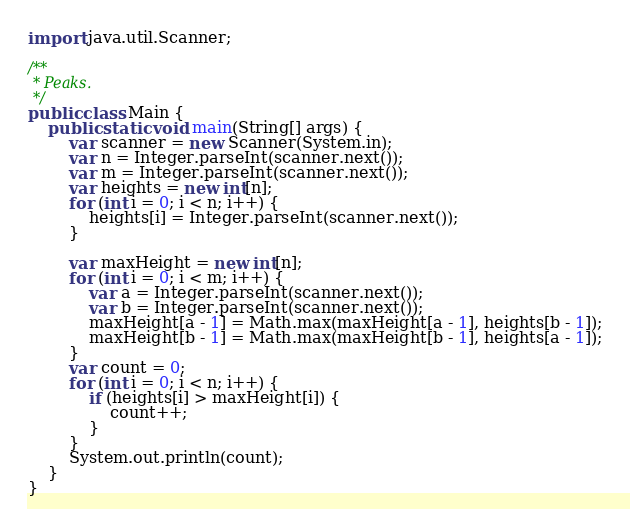<code> <loc_0><loc_0><loc_500><loc_500><_Java_>import java.util.Scanner;

/**
 * Peaks.
 */
public class Main {
    public static void main(String[] args) {
        var scanner = new Scanner(System.in);
        var n = Integer.parseInt(scanner.next());
        var m = Integer.parseInt(scanner.next());
        var heights = new int[n];
        for (int i = 0; i < n; i++) {
            heights[i] = Integer.parseInt(scanner.next());
        }

        var maxHeight = new int[n];
        for (int i = 0; i < m; i++) {
            var a = Integer.parseInt(scanner.next());
            var b = Integer.parseInt(scanner.next());
            maxHeight[a - 1] = Math.max(maxHeight[a - 1], heights[b - 1]);
            maxHeight[b - 1] = Math.max(maxHeight[b - 1], heights[a - 1]);
        }
        var count = 0;
        for (int i = 0; i < n; i++) {
            if (heights[i] > maxHeight[i]) {
                count++;
            }
        }
        System.out.println(count);
    }
}
</code> 